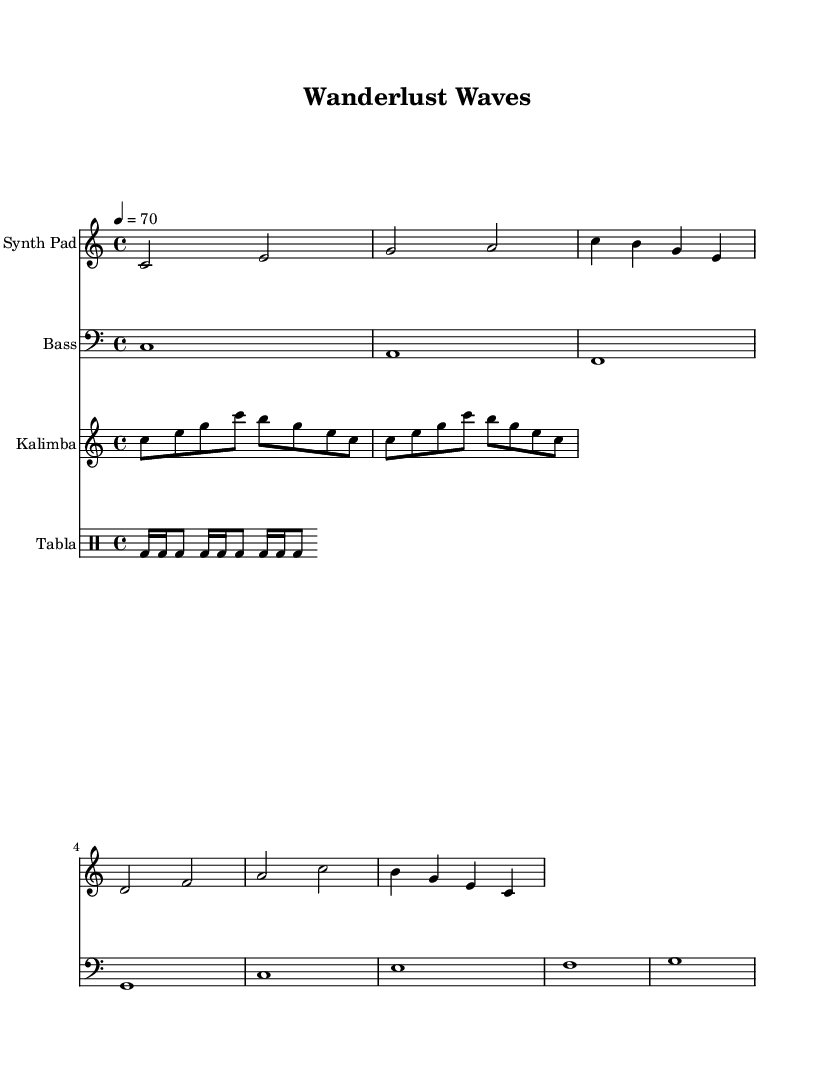What is the key signature of this music? The key signature is C major, which is indicated by no sharps or flats in the music. The C major scale consists of the notes C, D, E, F, G, A, and B.
Answer: C major What is the time signature of this piece? The time signature is 4/4, which is shown at the beginning of the score. This means there are four beats in each measure and a quarter note receives one beat.
Answer: 4/4 What is the tempo marking for this composition? The tempo is indicated as 4 = 70, which means there are 70 beats per minute, and each beat corresponds to a quarter note.
Answer: 70 How many measures are there in the Synth Pad part? By counting the distinct groups of notes between the measure bars in the Synth Pad part, there are a total of 8 measures.
Answer: 8 What rhythmic figure is predominantly used in the Tabla part? The Tabla part features a repeating pattern of bass drum notes, alternating between eighth and quarter notes, creating a distinctive rhythm throughout the piece.
Answer: bd16, bd8 What instruments are included in this score? The score includes four distinct instruments: Synth Pad, Bass, Kalimba, and Tabla. Each has its own staff showcasing its part, which is typical in layered electronic arrangements aimed for relaxation.
Answer: Synth Pad, Bass, Kalimba, Tabla What is the overall mood suggested by the music note arrangement? The combination of sustained sounds from the Synth Pad and Kalimba, alongside rhythmic elements from the Tabla, creates a soothing atmosphere that is characteristic of ambient electronic music, making it ideal for relaxation during travels.
Answer: Soothing 